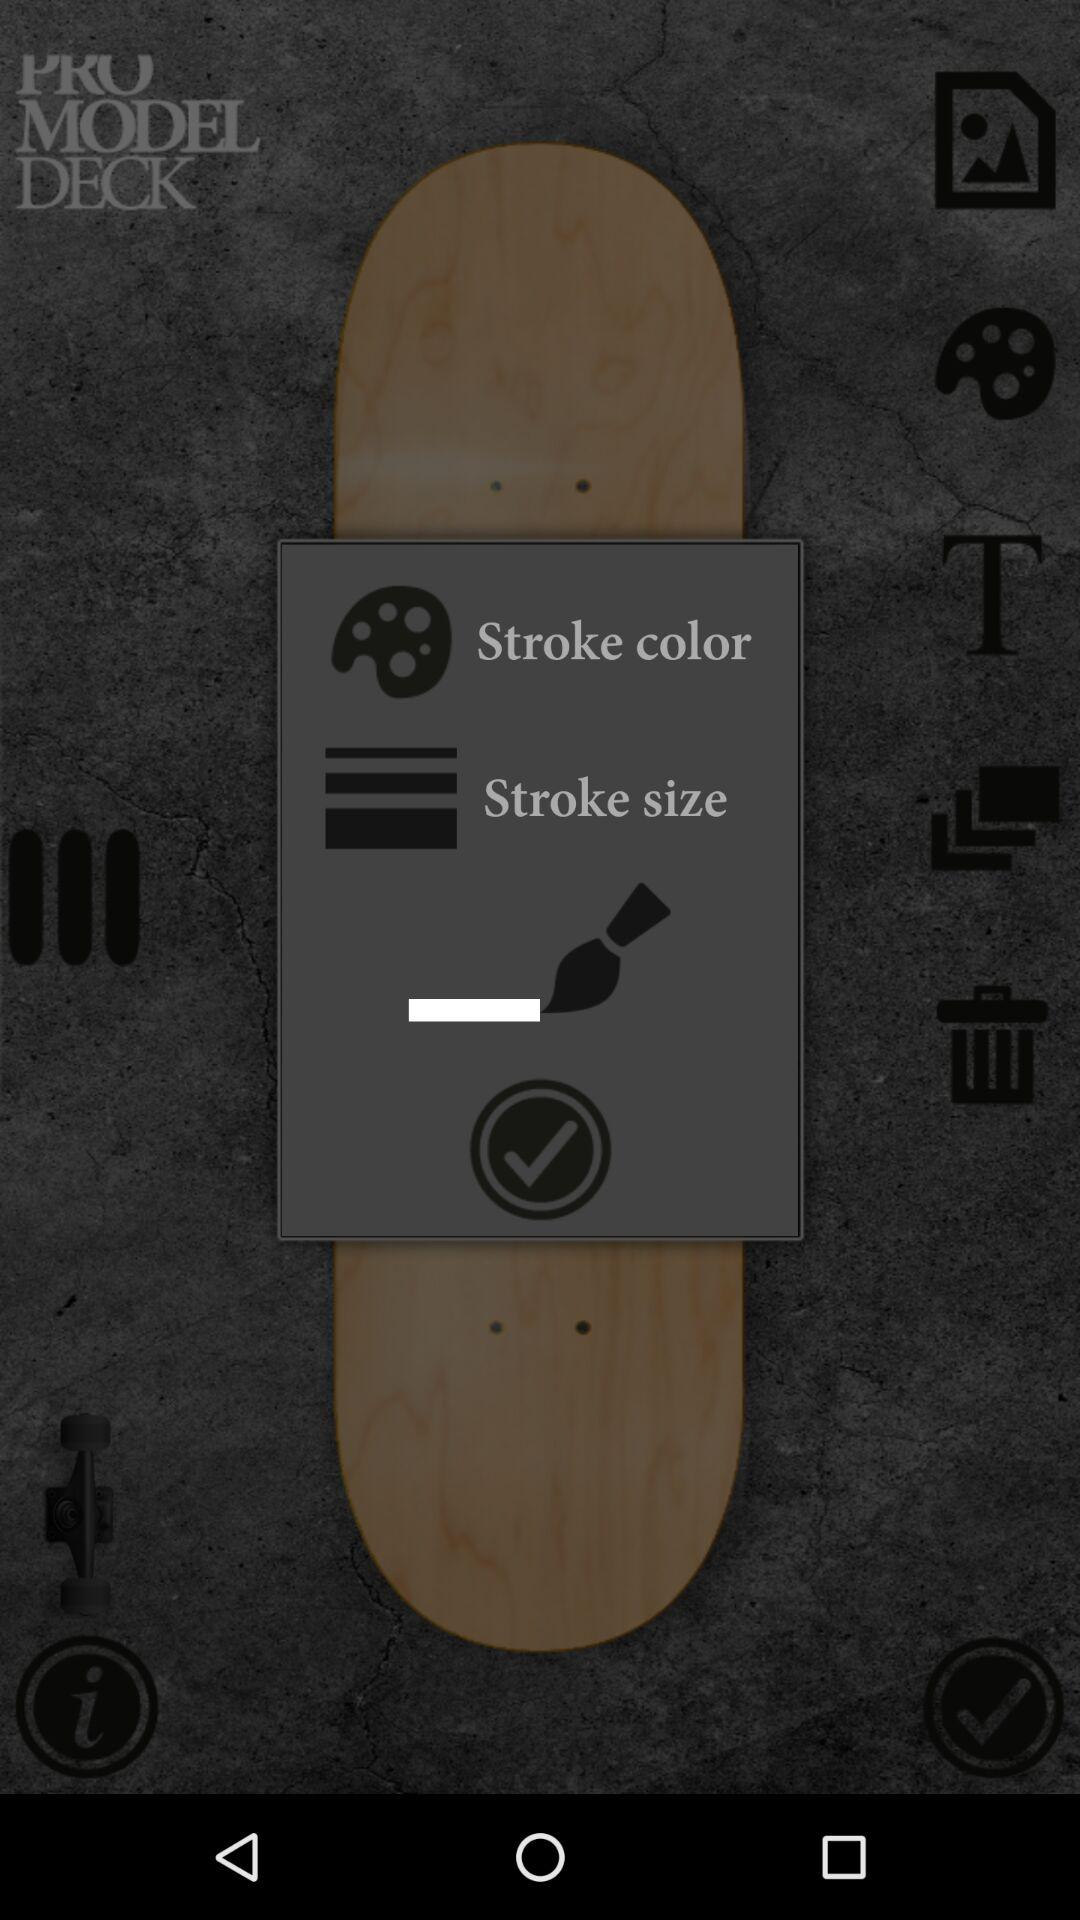How many more stroke size options are there than stroke color options?
Answer the question using a single word or phrase. 2 